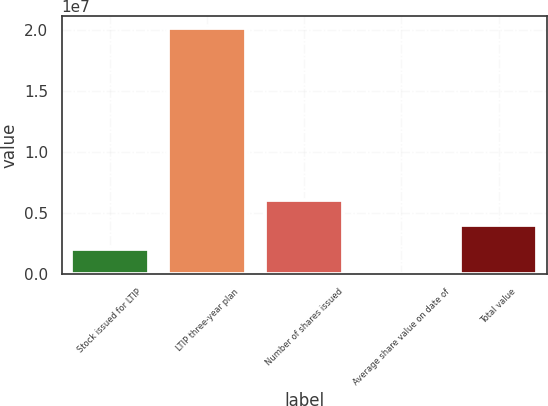<chart> <loc_0><loc_0><loc_500><loc_500><bar_chart><fcel>Stock issued for LTIP<fcel>LTIP three-year plan<fcel>Number of shares issued<fcel>Average share value on date of<fcel>Total value<nl><fcel>2.01429e+06<fcel>2.01415e+07<fcel>6.04256e+06<fcel>157.07<fcel>4.02843e+06<nl></chart> 